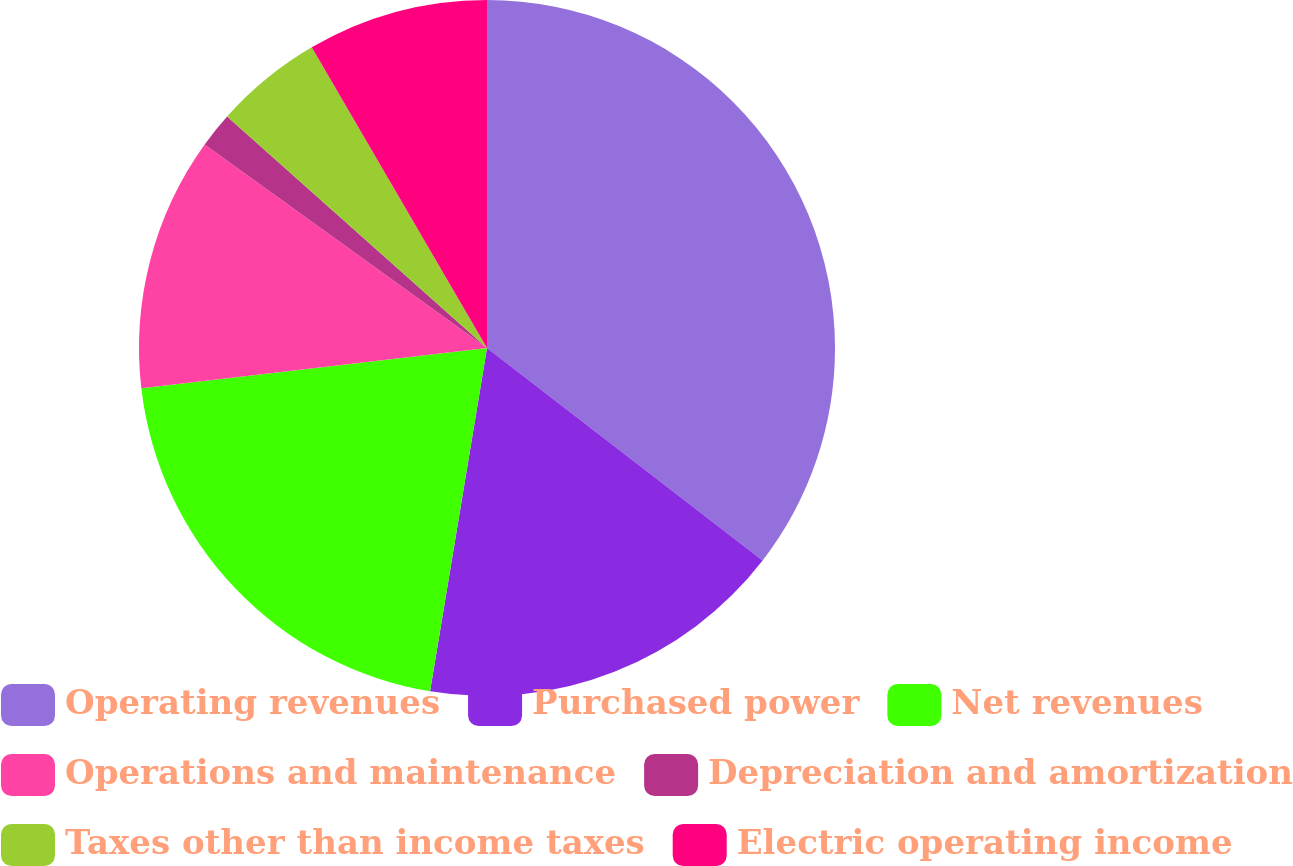Convert chart to OTSL. <chart><loc_0><loc_0><loc_500><loc_500><pie_chart><fcel>Operating revenues<fcel>Purchased power<fcel>Net revenues<fcel>Operations and maintenance<fcel>Depreciation and amortization<fcel>Taxes other than income taxes<fcel>Electric operating income<nl><fcel>35.45%<fcel>17.16%<fcel>20.54%<fcel>11.78%<fcel>1.64%<fcel>5.02%<fcel>8.4%<nl></chart> 